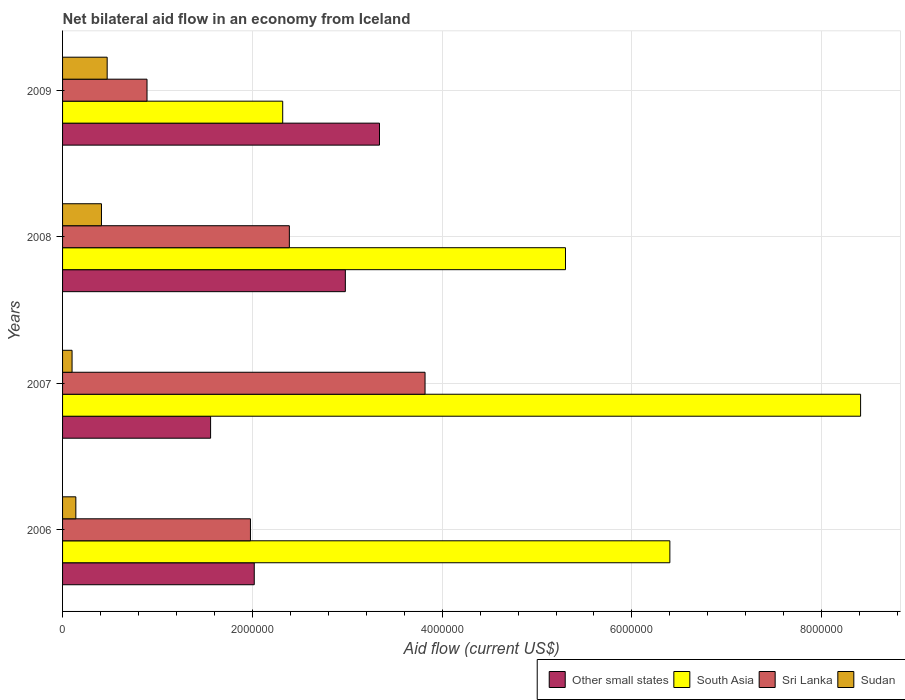How many groups of bars are there?
Make the answer very short. 4. Are the number of bars per tick equal to the number of legend labels?
Keep it short and to the point. Yes. Are the number of bars on each tick of the Y-axis equal?
Keep it short and to the point. Yes. How many bars are there on the 3rd tick from the top?
Give a very brief answer. 4. How many bars are there on the 3rd tick from the bottom?
Make the answer very short. 4. What is the net bilateral aid flow in South Asia in 2009?
Your answer should be very brief. 2.32e+06. Across all years, what is the maximum net bilateral aid flow in Sri Lanka?
Make the answer very short. 3.82e+06. Across all years, what is the minimum net bilateral aid flow in Sudan?
Provide a short and direct response. 1.00e+05. In which year was the net bilateral aid flow in Sri Lanka minimum?
Provide a succinct answer. 2009. What is the total net bilateral aid flow in Other small states in the graph?
Your answer should be very brief. 9.90e+06. What is the difference between the net bilateral aid flow in Other small states in 2006 and that in 2008?
Offer a terse response. -9.60e+05. What is the difference between the net bilateral aid flow in South Asia in 2009 and the net bilateral aid flow in Sri Lanka in 2007?
Provide a short and direct response. -1.50e+06. What is the average net bilateral aid flow in South Asia per year?
Provide a short and direct response. 5.61e+06. In the year 2006, what is the difference between the net bilateral aid flow in South Asia and net bilateral aid flow in Sri Lanka?
Your response must be concise. 4.42e+06. What is the ratio of the net bilateral aid flow in Other small states in 2008 to that in 2009?
Keep it short and to the point. 0.89. Is the difference between the net bilateral aid flow in South Asia in 2006 and 2009 greater than the difference between the net bilateral aid flow in Sri Lanka in 2006 and 2009?
Make the answer very short. Yes. What is the difference between the highest and the second highest net bilateral aid flow in South Asia?
Offer a very short reply. 2.01e+06. What is the difference between the highest and the lowest net bilateral aid flow in Other small states?
Provide a short and direct response. 1.78e+06. In how many years, is the net bilateral aid flow in Sri Lanka greater than the average net bilateral aid flow in Sri Lanka taken over all years?
Your response must be concise. 2. Is it the case that in every year, the sum of the net bilateral aid flow in Sudan and net bilateral aid flow in Other small states is greater than the sum of net bilateral aid flow in South Asia and net bilateral aid flow in Sri Lanka?
Offer a terse response. No. What does the 1st bar from the top in 2007 represents?
Make the answer very short. Sudan. What does the 4th bar from the bottom in 2009 represents?
Make the answer very short. Sudan. Are all the bars in the graph horizontal?
Ensure brevity in your answer.  Yes. How many years are there in the graph?
Keep it short and to the point. 4. What is the difference between two consecutive major ticks on the X-axis?
Keep it short and to the point. 2.00e+06. Are the values on the major ticks of X-axis written in scientific E-notation?
Ensure brevity in your answer.  No. Does the graph contain grids?
Make the answer very short. Yes. How many legend labels are there?
Offer a very short reply. 4. What is the title of the graph?
Offer a very short reply. Net bilateral aid flow in an economy from Iceland. Does "Colombia" appear as one of the legend labels in the graph?
Your answer should be compact. No. What is the Aid flow (current US$) of Other small states in 2006?
Keep it short and to the point. 2.02e+06. What is the Aid flow (current US$) of South Asia in 2006?
Make the answer very short. 6.40e+06. What is the Aid flow (current US$) of Sri Lanka in 2006?
Give a very brief answer. 1.98e+06. What is the Aid flow (current US$) in Sudan in 2006?
Your response must be concise. 1.40e+05. What is the Aid flow (current US$) of Other small states in 2007?
Give a very brief answer. 1.56e+06. What is the Aid flow (current US$) in South Asia in 2007?
Keep it short and to the point. 8.41e+06. What is the Aid flow (current US$) of Sri Lanka in 2007?
Provide a short and direct response. 3.82e+06. What is the Aid flow (current US$) in Other small states in 2008?
Provide a short and direct response. 2.98e+06. What is the Aid flow (current US$) in South Asia in 2008?
Provide a short and direct response. 5.30e+06. What is the Aid flow (current US$) in Sri Lanka in 2008?
Offer a terse response. 2.39e+06. What is the Aid flow (current US$) in Other small states in 2009?
Offer a terse response. 3.34e+06. What is the Aid flow (current US$) of South Asia in 2009?
Your response must be concise. 2.32e+06. What is the Aid flow (current US$) in Sri Lanka in 2009?
Offer a very short reply. 8.90e+05. What is the Aid flow (current US$) of Sudan in 2009?
Offer a terse response. 4.70e+05. Across all years, what is the maximum Aid flow (current US$) in Other small states?
Offer a very short reply. 3.34e+06. Across all years, what is the maximum Aid flow (current US$) of South Asia?
Your answer should be very brief. 8.41e+06. Across all years, what is the maximum Aid flow (current US$) in Sri Lanka?
Provide a succinct answer. 3.82e+06. Across all years, what is the maximum Aid flow (current US$) of Sudan?
Your response must be concise. 4.70e+05. Across all years, what is the minimum Aid flow (current US$) in Other small states?
Keep it short and to the point. 1.56e+06. Across all years, what is the minimum Aid flow (current US$) in South Asia?
Offer a very short reply. 2.32e+06. Across all years, what is the minimum Aid flow (current US$) of Sri Lanka?
Offer a very short reply. 8.90e+05. What is the total Aid flow (current US$) of Other small states in the graph?
Provide a succinct answer. 9.90e+06. What is the total Aid flow (current US$) of South Asia in the graph?
Provide a short and direct response. 2.24e+07. What is the total Aid flow (current US$) of Sri Lanka in the graph?
Give a very brief answer. 9.08e+06. What is the total Aid flow (current US$) of Sudan in the graph?
Offer a very short reply. 1.12e+06. What is the difference between the Aid flow (current US$) in Other small states in 2006 and that in 2007?
Offer a very short reply. 4.60e+05. What is the difference between the Aid flow (current US$) of South Asia in 2006 and that in 2007?
Offer a terse response. -2.01e+06. What is the difference between the Aid flow (current US$) in Sri Lanka in 2006 and that in 2007?
Offer a terse response. -1.84e+06. What is the difference between the Aid flow (current US$) in Sudan in 2006 and that in 2007?
Your response must be concise. 4.00e+04. What is the difference between the Aid flow (current US$) of Other small states in 2006 and that in 2008?
Keep it short and to the point. -9.60e+05. What is the difference between the Aid flow (current US$) in South Asia in 2006 and that in 2008?
Ensure brevity in your answer.  1.10e+06. What is the difference between the Aid flow (current US$) of Sri Lanka in 2006 and that in 2008?
Your answer should be very brief. -4.10e+05. What is the difference between the Aid flow (current US$) in Sudan in 2006 and that in 2008?
Your answer should be very brief. -2.70e+05. What is the difference between the Aid flow (current US$) of Other small states in 2006 and that in 2009?
Your answer should be very brief. -1.32e+06. What is the difference between the Aid flow (current US$) of South Asia in 2006 and that in 2009?
Make the answer very short. 4.08e+06. What is the difference between the Aid flow (current US$) in Sri Lanka in 2006 and that in 2009?
Provide a short and direct response. 1.09e+06. What is the difference between the Aid flow (current US$) in Sudan in 2006 and that in 2009?
Your answer should be compact. -3.30e+05. What is the difference between the Aid flow (current US$) in Other small states in 2007 and that in 2008?
Ensure brevity in your answer.  -1.42e+06. What is the difference between the Aid flow (current US$) in South Asia in 2007 and that in 2008?
Give a very brief answer. 3.11e+06. What is the difference between the Aid flow (current US$) of Sri Lanka in 2007 and that in 2008?
Make the answer very short. 1.43e+06. What is the difference between the Aid flow (current US$) of Sudan in 2007 and that in 2008?
Your response must be concise. -3.10e+05. What is the difference between the Aid flow (current US$) in Other small states in 2007 and that in 2009?
Provide a succinct answer. -1.78e+06. What is the difference between the Aid flow (current US$) of South Asia in 2007 and that in 2009?
Offer a very short reply. 6.09e+06. What is the difference between the Aid flow (current US$) in Sri Lanka in 2007 and that in 2009?
Your answer should be very brief. 2.93e+06. What is the difference between the Aid flow (current US$) of Sudan in 2007 and that in 2009?
Keep it short and to the point. -3.70e+05. What is the difference between the Aid flow (current US$) of Other small states in 2008 and that in 2009?
Ensure brevity in your answer.  -3.60e+05. What is the difference between the Aid flow (current US$) of South Asia in 2008 and that in 2009?
Ensure brevity in your answer.  2.98e+06. What is the difference between the Aid flow (current US$) of Sri Lanka in 2008 and that in 2009?
Offer a terse response. 1.50e+06. What is the difference between the Aid flow (current US$) of Other small states in 2006 and the Aid flow (current US$) of South Asia in 2007?
Your answer should be very brief. -6.39e+06. What is the difference between the Aid flow (current US$) in Other small states in 2006 and the Aid flow (current US$) in Sri Lanka in 2007?
Ensure brevity in your answer.  -1.80e+06. What is the difference between the Aid flow (current US$) of Other small states in 2006 and the Aid flow (current US$) of Sudan in 2007?
Provide a short and direct response. 1.92e+06. What is the difference between the Aid flow (current US$) in South Asia in 2006 and the Aid flow (current US$) in Sri Lanka in 2007?
Keep it short and to the point. 2.58e+06. What is the difference between the Aid flow (current US$) in South Asia in 2006 and the Aid flow (current US$) in Sudan in 2007?
Offer a terse response. 6.30e+06. What is the difference between the Aid flow (current US$) of Sri Lanka in 2006 and the Aid flow (current US$) of Sudan in 2007?
Keep it short and to the point. 1.88e+06. What is the difference between the Aid flow (current US$) in Other small states in 2006 and the Aid flow (current US$) in South Asia in 2008?
Your answer should be compact. -3.28e+06. What is the difference between the Aid flow (current US$) in Other small states in 2006 and the Aid flow (current US$) in Sri Lanka in 2008?
Ensure brevity in your answer.  -3.70e+05. What is the difference between the Aid flow (current US$) of Other small states in 2006 and the Aid flow (current US$) of Sudan in 2008?
Offer a terse response. 1.61e+06. What is the difference between the Aid flow (current US$) of South Asia in 2006 and the Aid flow (current US$) of Sri Lanka in 2008?
Ensure brevity in your answer.  4.01e+06. What is the difference between the Aid flow (current US$) of South Asia in 2006 and the Aid flow (current US$) of Sudan in 2008?
Ensure brevity in your answer.  5.99e+06. What is the difference between the Aid flow (current US$) in Sri Lanka in 2006 and the Aid flow (current US$) in Sudan in 2008?
Your response must be concise. 1.57e+06. What is the difference between the Aid flow (current US$) of Other small states in 2006 and the Aid flow (current US$) of South Asia in 2009?
Offer a very short reply. -3.00e+05. What is the difference between the Aid flow (current US$) in Other small states in 2006 and the Aid flow (current US$) in Sri Lanka in 2009?
Offer a very short reply. 1.13e+06. What is the difference between the Aid flow (current US$) in Other small states in 2006 and the Aid flow (current US$) in Sudan in 2009?
Offer a terse response. 1.55e+06. What is the difference between the Aid flow (current US$) of South Asia in 2006 and the Aid flow (current US$) of Sri Lanka in 2009?
Your response must be concise. 5.51e+06. What is the difference between the Aid flow (current US$) of South Asia in 2006 and the Aid flow (current US$) of Sudan in 2009?
Provide a succinct answer. 5.93e+06. What is the difference between the Aid flow (current US$) of Sri Lanka in 2006 and the Aid flow (current US$) of Sudan in 2009?
Your answer should be very brief. 1.51e+06. What is the difference between the Aid flow (current US$) of Other small states in 2007 and the Aid flow (current US$) of South Asia in 2008?
Provide a short and direct response. -3.74e+06. What is the difference between the Aid flow (current US$) in Other small states in 2007 and the Aid flow (current US$) in Sri Lanka in 2008?
Give a very brief answer. -8.30e+05. What is the difference between the Aid flow (current US$) in Other small states in 2007 and the Aid flow (current US$) in Sudan in 2008?
Give a very brief answer. 1.15e+06. What is the difference between the Aid flow (current US$) of South Asia in 2007 and the Aid flow (current US$) of Sri Lanka in 2008?
Your answer should be compact. 6.02e+06. What is the difference between the Aid flow (current US$) of South Asia in 2007 and the Aid flow (current US$) of Sudan in 2008?
Your answer should be compact. 8.00e+06. What is the difference between the Aid flow (current US$) of Sri Lanka in 2007 and the Aid flow (current US$) of Sudan in 2008?
Your answer should be compact. 3.41e+06. What is the difference between the Aid flow (current US$) in Other small states in 2007 and the Aid flow (current US$) in South Asia in 2009?
Provide a succinct answer. -7.60e+05. What is the difference between the Aid flow (current US$) of Other small states in 2007 and the Aid flow (current US$) of Sri Lanka in 2009?
Keep it short and to the point. 6.70e+05. What is the difference between the Aid flow (current US$) of Other small states in 2007 and the Aid flow (current US$) of Sudan in 2009?
Make the answer very short. 1.09e+06. What is the difference between the Aid flow (current US$) in South Asia in 2007 and the Aid flow (current US$) in Sri Lanka in 2009?
Provide a succinct answer. 7.52e+06. What is the difference between the Aid flow (current US$) of South Asia in 2007 and the Aid flow (current US$) of Sudan in 2009?
Your answer should be compact. 7.94e+06. What is the difference between the Aid flow (current US$) of Sri Lanka in 2007 and the Aid flow (current US$) of Sudan in 2009?
Give a very brief answer. 3.35e+06. What is the difference between the Aid flow (current US$) in Other small states in 2008 and the Aid flow (current US$) in Sri Lanka in 2009?
Give a very brief answer. 2.09e+06. What is the difference between the Aid flow (current US$) of Other small states in 2008 and the Aid flow (current US$) of Sudan in 2009?
Your response must be concise. 2.51e+06. What is the difference between the Aid flow (current US$) of South Asia in 2008 and the Aid flow (current US$) of Sri Lanka in 2009?
Keep it short and to the point. 4.41e+06. What is the difference between the Aid flow (current US$) of South Asia in 2008 and the Aid flow (current US$) of Sudan in 2009?
Your response must be concise. 4.83e+06. What is the difference between the Aid flow (current US$) of Sri Lanka in 2008 and the Aid flow (current US$) of Sudan in 2009?
Ensure brevity in your answer.  1.92e+06. What is the average Aid flow (current US$) in Other small states per year?
Offer a terse response. 2.48e+06. What is the average Aid flow (current US$) in South Asia per year?
Your answer should be very brief. 5.61e+06. What is the average Aid flow (current US$) in Sri Lanka per year?
Ensure brevity in your answer.  2.27e+06. In the year 2006, what is the difference between the Aid flow (current US$) of Other small states and Aid flow (current US$) of South Asia?
Your answer should be very brief. -4.38e+06. In the year 2006, what is the difference between the Aid flow (current US$) in Other small states and Aid flow (current US$) in Sudan?
Ensure brevity in your answer.  1.88e+06. In the year 2006, what is the difference between the Aid flow (current US$) of South Asia and Aid flow (current US$) of Sri Lanka?
Your answer should be compact. 4.42e+06. In the year 2006, what is the difference between the Aid flow (current US$) in South Asia and Aid flow (current US$) in Sudan?
Provide a succinct answer. 6.26e+06. In the year 2006, what is the difference between the Aid flow (current US$) in Sri Lanka and Aid flow (current US$) in Sudan?
Ensure brevity in your answer.  1.84e+06. In the year 2007, what is the difference between the Aid flow (current US$) of Other small states and Aid flow (current US$) of South Asia?
Offer a terse response. -6.85e+06. In the year 2007, what is the difference between the Aid flow (current US$) in Other small states and Aid flow (current US$) in Sri Lanka?
Provide a short and direct response. -2.26e+06. In the year 2007, what is the difference between the Aid flow (current US$) of Other small states and Aid flow (current US$) of Sudan?
Offer a terse response. 1.46e+06. In the year 2007, what is the difference between the Aid flow (current US$) of South Asia and Aid flow (current US$) of Sri Lanka?
Offer a very short reply. 4.59e+06. In the year 2007, what is the difference between the Aid flow (current US$) of South Asia and Aid flow (current US$) of Sudan?
Your answer should be very brief. 8.31e+06. In the year 2007, what is the difference between the Aid flow (current US$) of Sri Lanka and Aid flow (current US$) of Sudan?
Keep it short and to the point. 3.72e+06. In the year 2008, what is the difference between the Aid flow (current US$) of Other small states and Aid flow (current US$) of South Asia?
Give a very brief answer. -2.32e+06. In the year 2008, what is the difference between the Aid flow (current US$) of Other small states and Aid flow (current US$) of Sri Lanka?
Ensure brevity in your answer.  5.90e+05. In the year 2008, what is the difference between the Aid flow (current US$) in Other small states and Aid flow (current US$) in Sudan?
Ensure brevity in your answer.  2.57e+06. In the year 2008, what is the difference between the Aid flow (current US$) in South Asia and Aid flow (current US$) in Sri Lanka?
Your answer should be compact. 2.91e+06. In the year 2008, what is the difference between the Aid flow (current US$) in South Asia and Aid flow (current US$) in Sudan?
Keep it short and to the point. 4.89e+06. In the year 2008, what is the difference between the Aid flow (current US$) of Sri Lanka and Aid flow (current US$) of Sudan?
Your answer should be compact. 1.98e+06. In the year 2009, what is the difference between the Aid flow (current US$) of Other small states and Aid flow (current US$) of South Asia?
Offer a terse response. 1.02e+06. In the year 2009, what is the difference between the Aid flow (current US$) in Other small states and Aid flow (current US$) in Sri Lanka?
Give a very brief answer. 2.45e+06. In the year 2009, what is the difference between the Aid flow (current US$) in Other small states and Aid flow (current US$) in Sudan?
Provide a short and direct response. 2.87e+06. In the year 2009, what is the difference between the Aid flow (current US$) of South Asia and Aid flow (current US$) of Sri Lanka?
Your answer should be very brief. 1.43e+06. In the year 2009, what is the difference between the Aid flow (current US$) in South Asia and Aid flow (current US$) in Sudan?
Provide a short and direct response. 1.85e+06. What is the ratio of the Aid flow (current US$) in Other small states in 2006 to that in 2007?
Your answer should be compact. 1.29. What is the ratio of the Aid flow (current US$) of South Asia in 2006 to that in 2007?
Offer a very short reply. 0.76. What is the ratio of the Aid flow (current US$) of Sri Lanka in 2006 to that in 2007?
Your answer should be very brief. 0.52. What is the ratio of the Aid flow (current US$) in Sudan in 2006 to that in 2007?
Your response must be concise. 1.4. What is the ratio of the Aid flow (current US$) in Other small states in 2006 to that in 2008?
Your response must be concise. 0.68. What is the ratio of the Aid flow (current US$) of South Asia in 2006 to that in 2008?
Offer a terse response. 1.21. What is the ratio of the Aid flow (current US$) of Sri Lanka in 2006 to that in 2008?
Your response must be concise. 0.83. What is the ratio of the Aid flow (current US$) of Sudan in 2006 to that in 2008?
Your answer should be very brief. 0.34. What is the ratio of the Aid flow (current US$) in Other small states in 2006 to that in 2009?
Your answer should be very brief. 0.6. What is the ratio of the Aid flow (current US$) in South Asia in 2006 to that in 2009?
Provide a succinct answer. 2.76. What is the ratio of the Aid flow (current US$) in Sri Lanka in 2006 to that in 2009?
Keep it short and to the point. 2.22. What is the ratio of the Aid flow (current US$) in Sudan in 2006 to that in 2009?
Your answer should be very brief. 0.3. What is the ratio of the Aid flow (current US$) of Other small states in 2007 to that in 2008?
Give a very brief answer. 0.52. What is the ratio of the Aid flow (current US$) of South Asia in 2007 to that in 2008?
Keep it short and to the point. 1.59. What is the ratio of the Aid flow (current US$) of Sri Lanka in 2007 to that in 2008?
Make the answer very short. 1.6. What is the ratio of the Aid flow (current US$) of Sudan in 2007 to that in 2008?
Ensure brevity in your answer.  0.24. What is the ratio of the Aid flow (current US$) of Other small states in 2007 to that in 2009?
Ensure brevity in your answer.  0.47. What is the ratio of the Aid flow (current US$) of South Asia in 2007 to that in 2009?
Provide a short and direct response. 3.62. What is the ratio of the Aid flow (current US$) of Sri Lanka in 2007 to that in 2009?
Make the answer very short. 4.29. What is the ratio of the Aid flow (current US$) of Sudan in 2007 to that in 2009?
Offer a very short reply. 0.21. What is the ratio of the Aid flow (current US$) of Other small states in 2008 to that in 2009?
Ensure brevity in your answer.  0.89. What is the ratio of the Aid flow (current US$) of South Asia in 2008 to that in 2009?
Provide a succinct answer. 2.28. What is the ratio of the Aid flow (current US$) in Sri Lanka in 2008 to that in 2009?
Give a very brief answer. 2.69. What is the ratio of the Aid flow (current US$) in Sudan in 2008 to that in 2009?
Keep it short and to the point. 0.87. What is the difference between the highest and the second highest Aid flow (current US$) in South Asia?
Offer a terse response. 2.01e+06. What is the difference between the highest and the second highest Aid flow (current US$) of Sri Lanka?
Provide a succinct answer. 1.43e+06. What is the difference between the highest and the lowest Aid flow (current US$) in Other small states?
Keep it short and to the point. 1.78e+06. What is the difference between the highest and the lowest Aid flow (current US$) in South Asia?
Your answer should be compact. 6.09e+06. What is the difference between the highest and the lowest Aid flow (current US$) of Sri Lanka?
Your answer should be compact. 2.93e+06. What is the difference between the highest and the lowest Aid flow (current US$) of Sudan?
Your answer should be compact. 3.70e+05. 